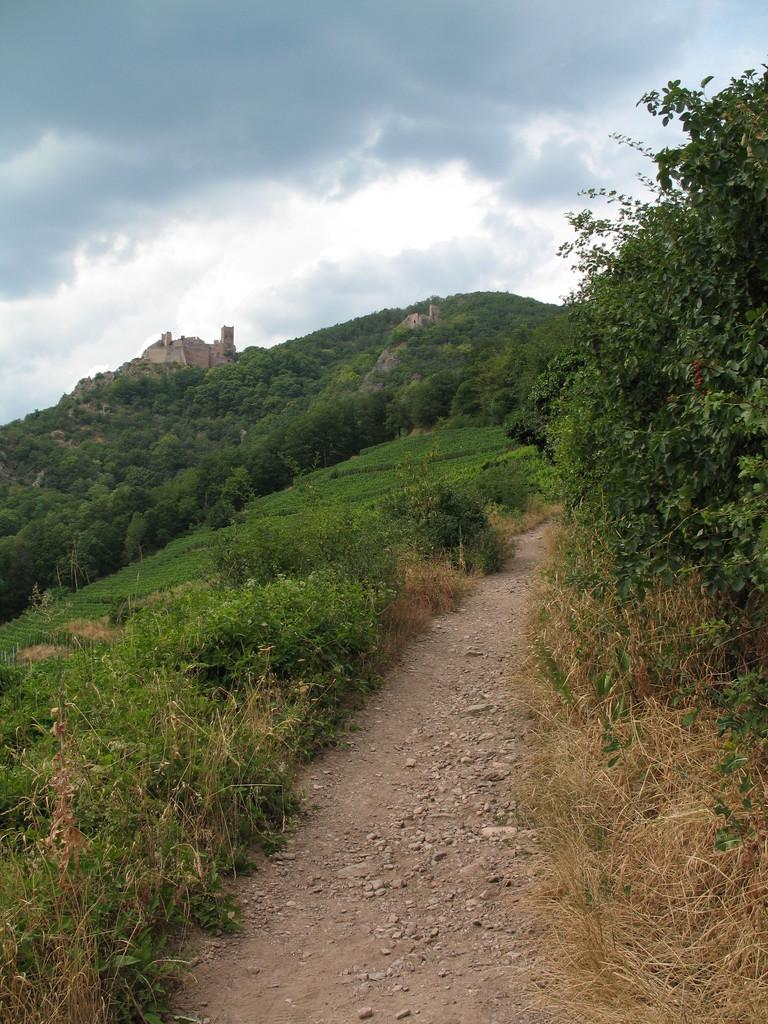What type of natural elements can be seen in the image? There are plants, trees, and stones visible in the image. What type of terrain is present in the image? There is land and a hill in the image. What man-made structure can be seen in the image? There is a fort in the image. What is visible in the sky in the image? The sky is visible in the image, and there are clouds present. What type of test is being conducted in the image? There is no indication of a test being conducted in the image. What type of business is represented in the image? There is no business represented in the image. 